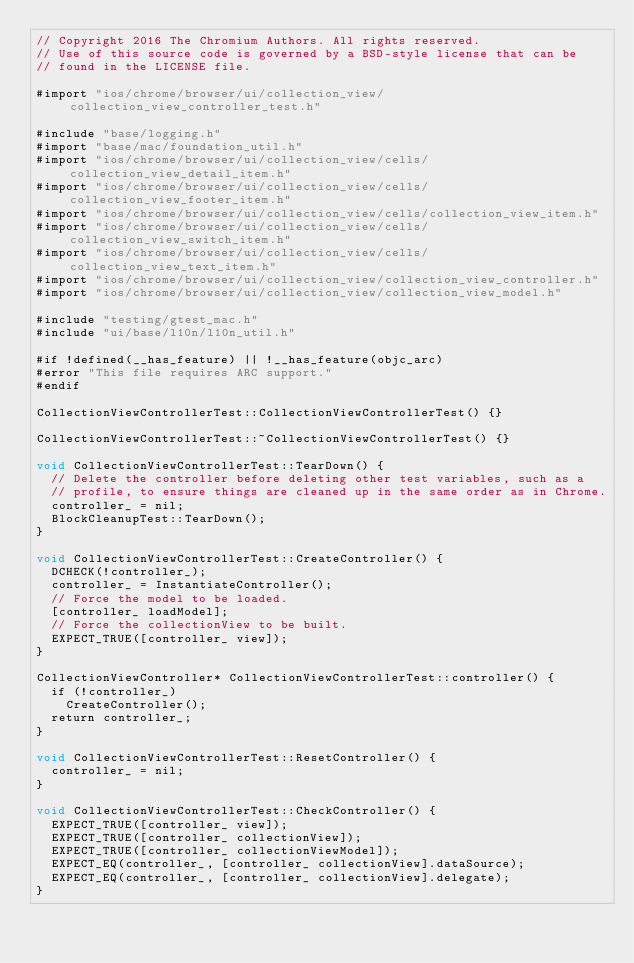<code> <loc_0><loc_0><loc_500><loc_500><_ObjectiveC_>// Copyright 2016 The Chromium Authors. All rights reserved.
// Use of this source code is governed by a BSD-style license that can be
// found in the LICENSE file.

#import "ios/chrome/browser/ui/collection_view/collection_view_controller_test.h"

#include "base/logging.h"
#import "base/mac/foundation_util.h"
#import "ios/chrome/browser/ui/collection_view/cells/collection_view_detail_item.h"
#import "ios/chrome/browser/ui/collection_view/cells/collection_view_footer_item.h"
#import "ios/chrome/browser/ui/collection_view/cells/collection_view_item.h"
#import "ios/chrome/browser/ui/collection_view/cells/collection_view_switch_item.h"
#import "ios/chrome/browser/ui/collection_view/cells/collection_view_text_item.h"
#import "ios/chrome/browser/ui/collection_view/collection_view_controller.h"
#import "ios/chrome/browser/ui/collection_view/collection_view_model.h"

#include "testing/gtest_mac.h"
#include "ui/base/l10n/l10n_util.h"

#if !defined(__has_feature) || !__has_feature(objc_arc)
#error "This file requires ARC support."
#endif

CollectionViewControllerTest::CollectionViewControllerTest() {}

CollectionViewControllerTest::~CollectionViewControllerTest() {}

void CollectionViewControllerTest::TearDown() {
  // Delete the controller before deleting other test variables, such as a
  // profile, to ensure things are cleaned up in the same order as in Chrome.
  controller_ = nil;
  BlockCleanupTest::TearDown();
}

void CollectionViewControllerTest::CreateController() {
  DCHECK(!controller_);
  controller_ = InstantiateController();
  // Force the model to be loaded.
  [controller_ loadModel];
  // Force the collectionView to be built.
  EXPECT_TRUE([controller_ view]);
}

CollectionViewController* CollectionViewControllerTest::controller() {
  if (!controller_)
    CreateController();
  return controller_;
}

void CollectionViewControllerTest::ResetController() {
  controller_ = nil;
}

void CollectionViewControllerTest::CheckController() {
  EXPECT_TRUE([controller_ view]);
  EXPECT_TRUE([controller_ collectionView]);
  EXPECT_TRUE([controller_ collectionViewModel]);
  EXPECT_EQ(controller_, [controller_ collectionView].dataSource);
  EXPECT_EQ(controller_, [controller_ collectionView].delegate);
}
</code> 